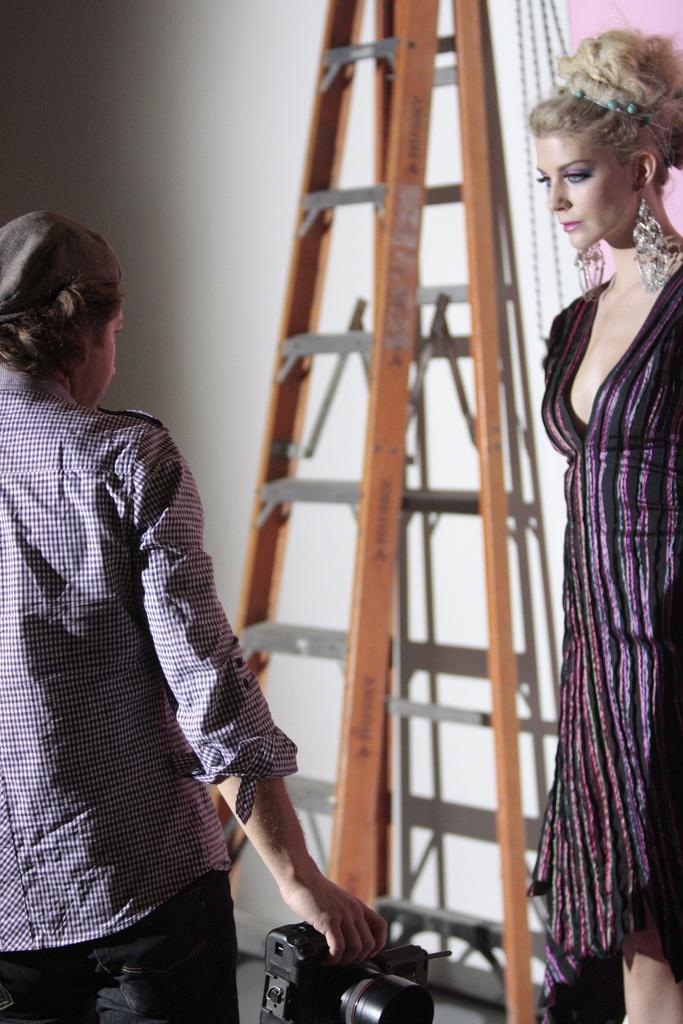In one or two sentences, can you explain what this image depicts? There is a man and woman here. Man is holding camera in his hand. Behind them there is a wall and ladder. 